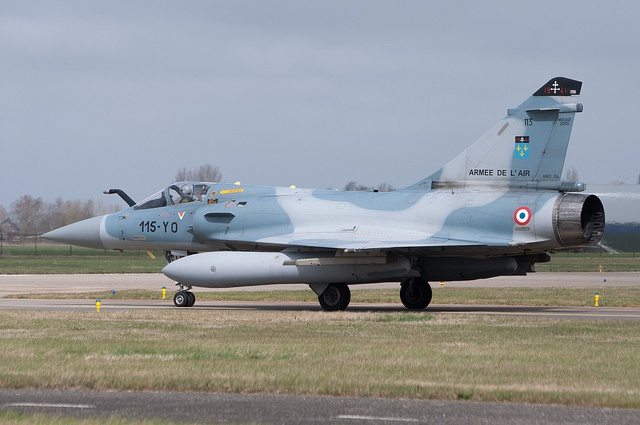Describe the objects in this image and their specific colors. I can see airplane in darkgray, black, and lightgray tones, people in darkgray and gray tones, and people in darkgray and gray tones in this image. 